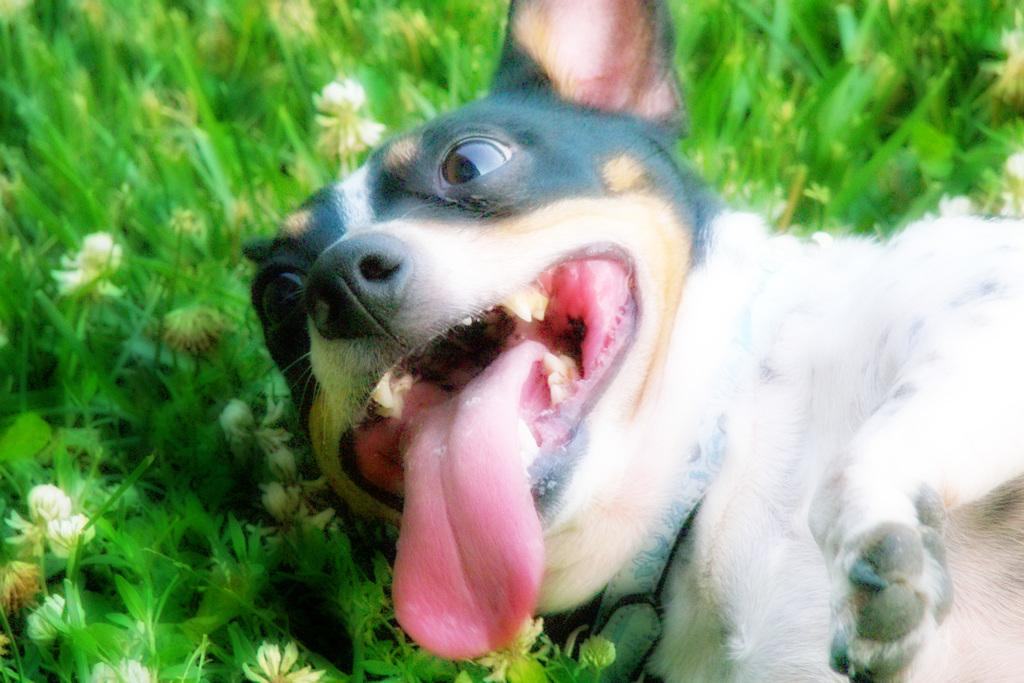What animal is present in the image? There is a dog in the image. What colors can be seen on the dog? The dog is black and white in color. What is the dog doing in the image? The dog is laying on the ground. What type of vegetation is on the left side of the image? There is green color grass on the left side of the image. Are there any flowers visible in the image? Yes, there are white color flowers on the left side of the image. How many brothers does the dog have in the image? There is no information about the dog's brothers in the image. What type of land is visible in the image? The image does not show any specific type of land; it only shows grass and flowers. 